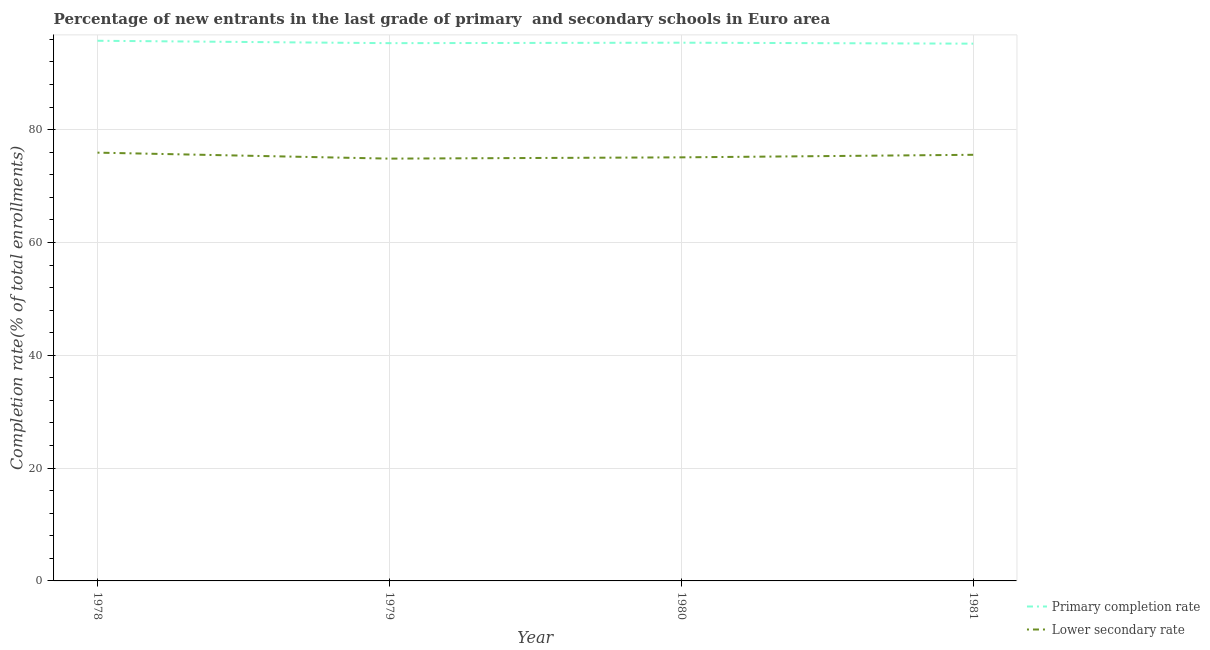Does the line corresponding to completion rate in primary schools intersect with the line corresponding to completion rate in secondary schools?
Offer a terse response. No. Is the number of lines equal to the number of legend labels?
Provide a short and direct response. Yes. What is the completion rate in secondary schools in 1978?
Provide a succinct answer. 75.93. Across all years, what is the maximum completion rate in secondary schools?
Offer a terse response. 75.93. Across all years, what is the minimum completion rate in secondary schools?
Your answer should be very brief. 74.87. In which year was the completion rate in secondary schools maximum?
Give a very brief answer. 1978. What is the total completion rate in secondary schools in the graph?
Provide a succinct answer. 301.43. What is the difference between the completion rate in primary schools in 1979 and that in 1980?
Give a very brief answer. -0.08. What is the difference between the completion rate in secondary schools in 1981 and the completion rate in primary schools in 1978?
Offer a very short reply. -20.21. What is the average completion rate in secondary schools per year?
Your response must be concise. 75.36. In the year 1981, what is the difference between the completion rate in secondary schools and completion rate in primary schools?
Provide a short and direct response. -19.7. In how many years, is the completion rate in secondary schools greater than 28 %?
Ensure brevity in your answer.  4. What is the ratio of the completion rate in secondary schools in 1979 to that in 1980?
Ensure brevity in your answer.  1. Is the difference between the completion rate in primary schools in 1980 and 1981 greater than the difference between the completion rate in secondary schools in 1980 and 1981?
Provide a succinct answer. Yes. What is the difference between the highest and the second highest completion rate in secondary schools?
Ensure brevity in your answer.  0.38. What is the difference between the highest and the lowest completion rate in secondary schools?
Your answer should be compact. 1.06. Is the sum of the completion rate in primary schools in 1979 and 1980 greater than the maximum completion rate in secondary schools across all years?
Your answer should be very brief. Yes. Does the completion rate in primary schools monotonically increase over the years?
Make the answer very short. No. How many years are there in the graph?
Your answer should be compact. 4. What is the difference between two consecutive major ticks on the Y-axis?
Keep it short and to the point. 20. How many legend labels are there?
Your answer should be compact. 2. What is the title of the graph?
Give a very brief answer. Percentage of new entrants in the last grade of primary  and secondary schools in Euro area. What is the label or title of the Y-axis?
Provide a short and direct response. Completion rate(% of total enrollments). What is the Completion rate(% of total enrollments) of Primary completion rate in 1978?
Your answer should be very brief. 95.76. What is the Completion rate(% of total enrollments) in Lower secondary rate in 1978?
Ensure brevity in your answer.  75.93. What is the Completion rate(% of total enrollments) in Primary completion rate in 1979?
Your response must be concise. 95.34. What is the Completion rate(% of total enrollments) of Lower secondary rate in 1979?
Provide a succinct answer. 74.87. What is the Completion rate(% of total enrollments) in Primary completion rate in 1980?
Offer a very short reply. 95.42. What is the Completion rate(% of total enrollments) in Lower secondary rate in 1980?
Make the answer very short. 75.09. What is the Completion rate(% of total enrollments) in Primary completion rate in 1981?
Your response must be concise. 95.25. What is the Completion rate(% of total enrollments) in Lower secondary rate in 1981?
Your answer should be very brief. 75.54. Across all years, what is the maximum Completion rate(% of total enrollments) in Primary completion rate?
Make the answer very short. 95.76. Across all years, what is the maximum Completion rate(% of total enrollments) of Lower secondary rate?
Offer a terse response. 75.93. Across all years, what is the minimum Completion rate(% of total enrollments) in Primary completion rate?
Provide a short and direct response. 95.25. Across all years, what is the minimum Completion rate(% of total enrollments) of Lower secondary rate?
Offer a terse response. 74.87. What is the total Completion rate(% of total enrollments) of Primary completion rate in the graph?
Your response must be concise. 381.76. What is the total Completion rate(% of total enrollments) in Lower secondary rate in the graph?
Offer a terse response. 301.43. What is the difference between the Completion rate(% of total enrollments) in Primary completion rate in 1978 and that in 1979?
Keep it short and to the point. 0.42. What is the difference between the Completion rate(% of total enrollments) in Lower secondary rate in 1978 and that in 1979?
Your answer should be very brief. 1.06. What is the difference between the Completion rate(% of total enrollments) in Primary completion rate in 1978 and that in 1980?
Provide a succinct answer. 0.34. What is the difference between the Completion rate(% of total enrollments) of Lower secondary rate in 1978 and that in 1980?
Your response must be concise. 0.83. What is the difference between the Completion rate(% of total enrollments) of Primary completion rate in 1978 and that in 1981?
Your answer should be compact. 0.51. What is the difference between the Completion rate(% of total enrollments) of Lower secondary rate in 1978 and that in 1981?
Offer a terse response. 0.38. What is the difference between the Completion rate(% of total enrollments) of Primary completion rate in 1979 and that in 1980?
Offer a very short reply. -0.08. What is the difference between the Completion rate(% of total enrollments) in Lower secondary rate in 1979 and that in 1980?
Offer a very short reply. -0.23. What is the difference between the Completion rate(% of total enrollments) in Primary completion rate in 1979 and that in 1981?
Your answer should be compact. 0.09. What is the difference between the Completion rate(% of total enrollments) of Lower secondary rate in 1979 and that in 1981?
Keep it short and to the point. -0.68. What is the difference between the Completion rate(% of total enrollments) in Primary completion rate in 1980 and that in 1981?
Ensure brevity in your answer.  0.17. What is the difference between the Completion rate(% of total enrollments) of Lower secondary rate in 1980 and that in 1981?
Give a very brief answer. -0.45. What is the difference between the Completion rate(% of total enrollments) in Primary completion rate in 1978 and the Completion rate(% of total enrollments) in Lower secondary rate in 1979?
Provide a succinct answer. 20.89. What is the difference between the Completion rate(% of total enrollments) in Primary completion rate in 1978 and the Completion rate(% of total enrollments) in Lower secondary rate in 1980?
Offer a terse response. 20.67. What is the difference between the Completion rate(% of total enrollments) of Primary completion rate in 1978 and the Completion rate(% of total enrollments) of Lower secondary rate in 1981?
Make the answer very short. 20.21. What is the difference between the Completion rate(% of total enrollments) in Primary completion rate in 1979 and the Completion rate(% of total enrollments) in Lower secondary rate in 1980?
Provide a succinct answer. 20.24. What is the difference between the Completion rate(% of total enrollments) in Primary completion rate in 1979 and the Completion rate(% of total enrollments) in Lower secondary rate in 1981?
Offer a terse response. 19.79. What is the difference between the Completion rate(% of total enrollments) of Primary completion rate in 1980 and the Completion rate(% of total enrollments) of Lower secondary rate in 1981?
Make the answer very short. 19.87. What is the average Completion rate(% of total enrollments) in Primary completion rate per year?
Make the answer very short. 95.44. What is the average Completion rate(% of total enrollments) in Lower secondary rate per year?
Your answer should be very brief. 75.36. In the year 1978, what is the difference between the Completion rate(% of total enrollments) of Primary completion rate and Completion rate(% of total enrollments) of Lower secondary rate?
Provide a succinct answer. 19.83. In the year 1979, what is the difference between the Completion rate(% of total enrollments) in Primary completion rate and Completion rate(% of total enrollments) in Lower secondary rate?
Make the answer very short. 20.47. In the year 1980, what is the difference between the Completion rate(% of total enrollments) in Primary completion rate and Completion rate(% of total enrollments) in Lower secondary rate?
Offer a very short reply. 20.33. In the year 1981, what is the difference between the Completion rate(% of total enrollments) in Primary completion rate and Completion rate(% of total enrollments) in Lower secondary rate?
Provide a short and direct response. 19.7. What is the ratio of the Completion rate(% of total enrollments) of Primary completion rate in 1978 to that in 1979?
Keep it short and to the point. 1. What is the ratio of the Completion rate(% of total enrollments) in Lower secondary rate in 1978 to that in 1979?
Your response must be concise. 1.01. What is the ratio of the Completion rate(% of total enrollments) of Primary completion rate in 1978 to that in 1980?
Your answer should be very brief. 1. What is the ratio of the Completion rate(% of total enrollments) of Lower secondary rate in 1978 to that in 1980?
Offer a terse response. 1.01. What is the ratio of the Completion rate(% of total enrollments) in Primary completion rate in 1978 to that in 1981?
Make the answer very short. 1.01. What is the ratio of the Completion rate(% of total enrollments) in Lower secondary rate in 1978 to that in 1981?
Offer a terse response. 1. What is the ratio of the Completion rate(% of total enrollments) of Primary completion rate in 1979 to that in 1980?
Make the answer very short. 1. What is the ratio of the Completion rate(% of total enrollments) in Lower secondary rate in 1979 to that in 1980?
Provide a succinct answer. 1. What is the ratio of the Completion rate(% of total enrollments) of Lower secondary rate in 1979 to that in 1981?
Your answer should be compact. 0.99. What is the ratio of the Completion rate(% of total enrollments) of Lower secondary rate in 1980 to that in 1981?
Give a very brief answer. 0.99. What is the difference between the highest and the second highest Completion rate(% of total enrollments) in Primary completion rate?
Provide a short and direct response. 0.34. What is the difference between the highest and the second highest Completion rate(% of total enrollments) in Lower secondary rate?
Make the answer very short. 0.38. What is the difference between the highest and the lowest Completion rate(% of total enrollments) in Primary completion rate?
Provide a short and direct response. 0.51. What is the difference between the highest and the lowest Completion rate(% of total enrollments) of Lower secondary rate?
Your response must be concise. 1.06. 